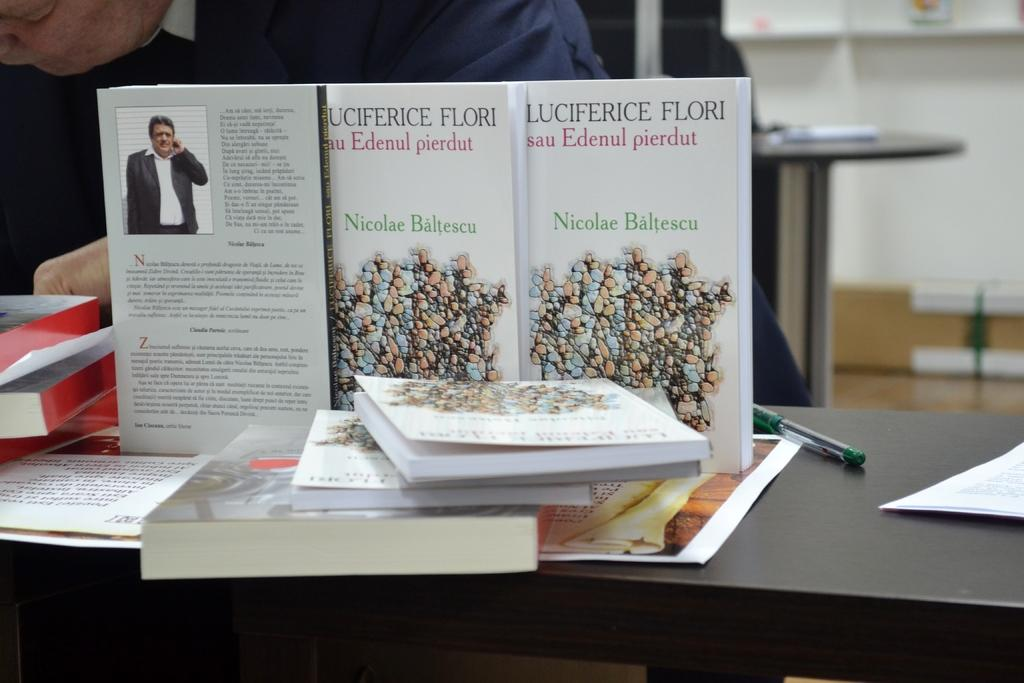<image>
Share a concise interpretation of the image provided. a book that has the name Nicolae on the cover 